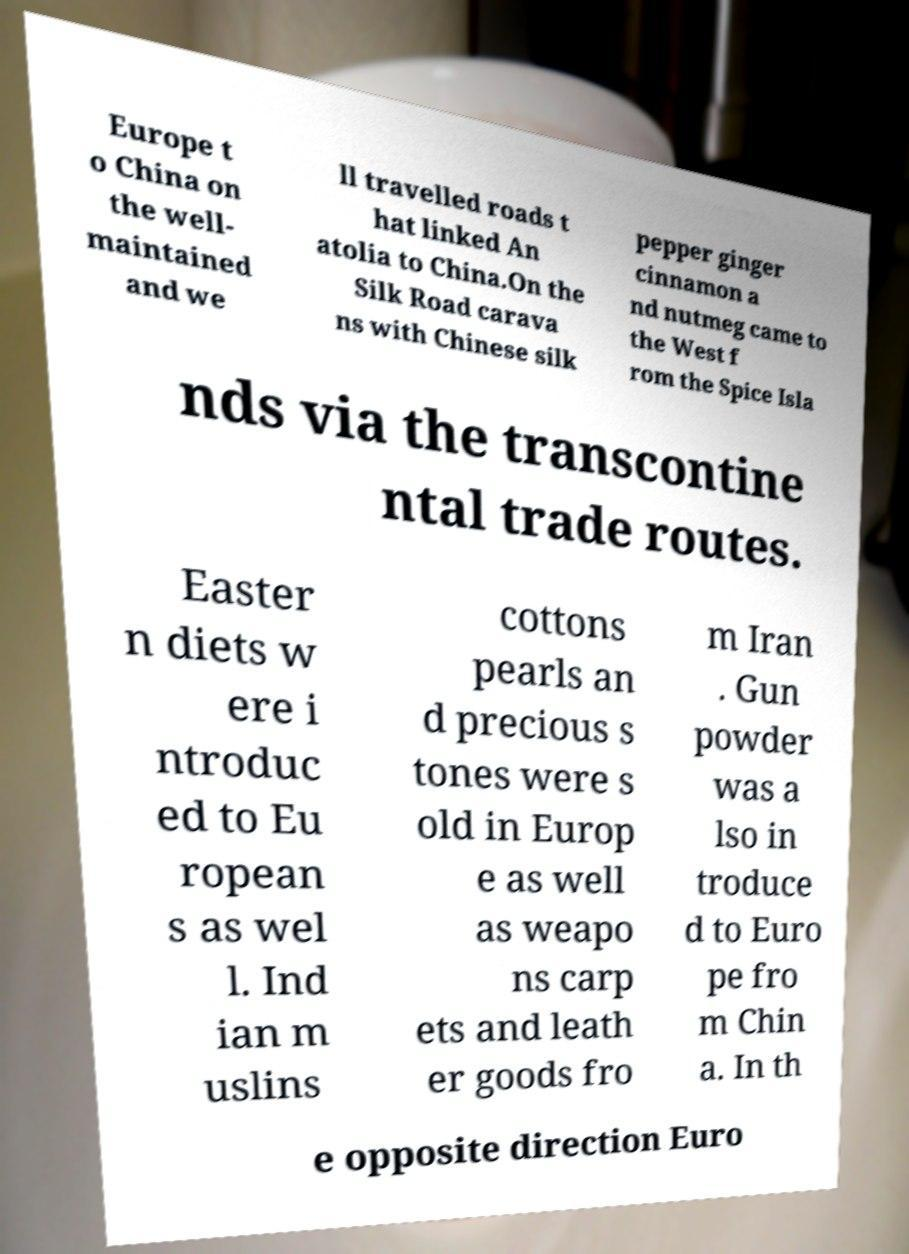Can you read and provide the text displayed in the image?This photo seems to have some interesting text. Can you extract and type it out for me? Europe t o China on the well- maintained and we ll travelled roads t hat linked An atolia to China.On the Silk Road carava ns with Chinese silk pepper ginger cinnamon a nd nutmeg came to the West f rom the Spice Isla nds via the transcontine ntal trade routes. Easter n diets w ere i ntroduc ed to Eu ropean s as wel l. Ind ian m uslins cottons pearls an d precious s tones were s old in Europ e as well as weapo ns carp ets and leath er goods fro m Iran . Gun powder was a lso in troduce d to Euro pe fro m Chin a. In th e opposite direction Euro 